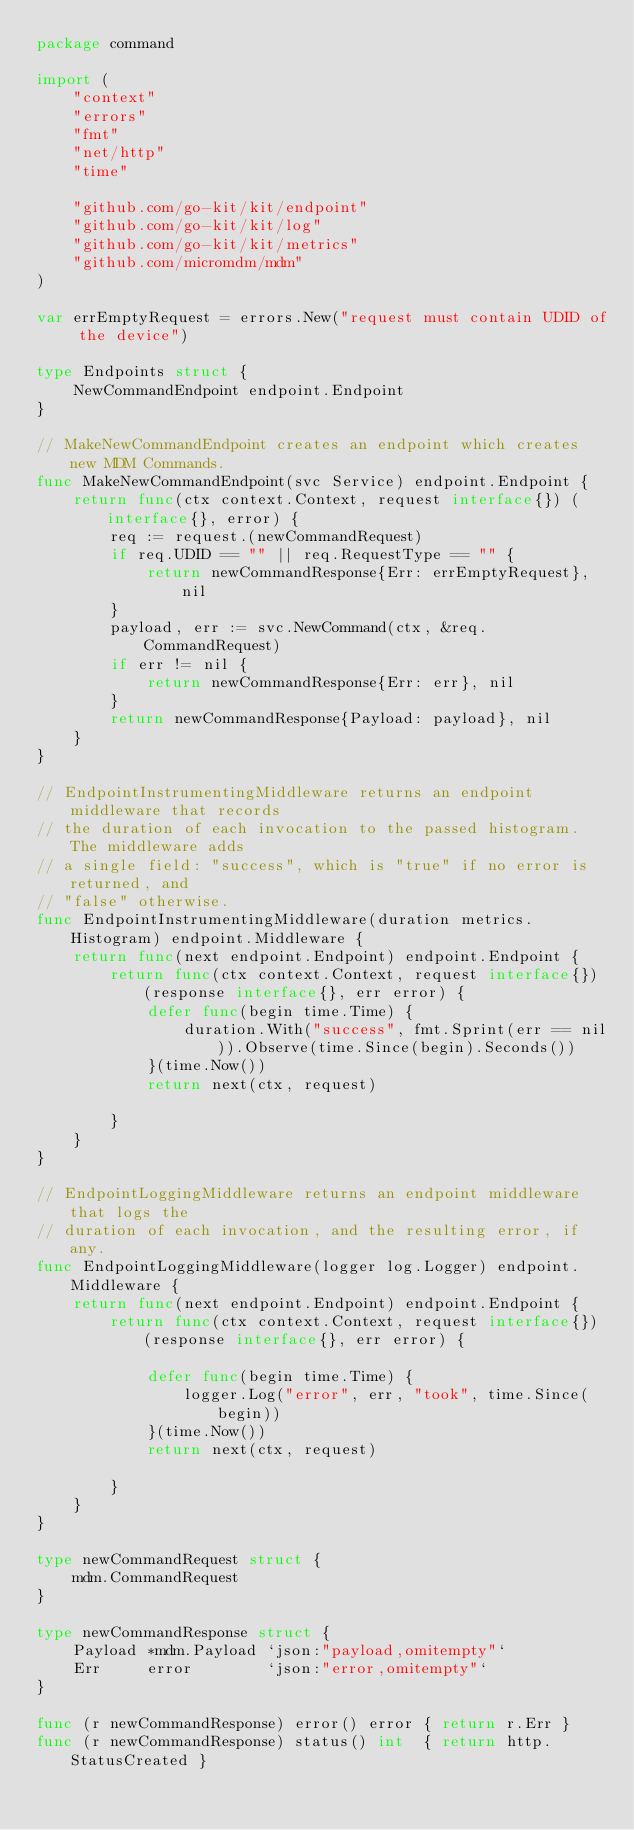<code> <loc_0><loc_0><loc_500><loc_500><_Go_>package command

import (
	"context"
	"errors"
	"fmt"
	"net/http"
	"time"

	"github.com/go-kit/kit/endpoint"
	"github.com/go-kit/kit/log"
	"github.com/go-kit/kit/metrics"
	"github.com/micromdm/mdm"
)

var errEmptyRequest = errors.New("request must contain UDID of the device")

type Endpoints struct {
	NewCommandEndpoint endpoint.Endpoint
}

// MakeNewCommandEndpoint creates an endpoint which creates new MDM Commands.
func MakeNewCommandEndpoint(svc Service) endpoint.Endpoint {
	return func(ctx context.Context, request interface{}) (interface{}, error) {
		req := request.(newCommandRequest)
		if req.UDID == "" || req.RequestType == "" {
			return newCommandResponse{Err: errEmptyRequest}, nil
		}
		payload, err := svc.NewCommand(ctx, &req.CommandRequest)
		if err != nil {
			return newCommandResponse{Err: err}, nil
		}
		return newCommandResponse{Payload: payload}, nil
	}
}

// EndpointInstrumentingMiddleware returns an endpoint middleware that records
// the duration of each invocation to the passed histogram. The middleware adds
// a single field: "success", which is "true" if no error is returned, and
// "false" otherwise.
func EndpointInstrumentingMiddleware(duration metrics.Histogram) endpoint.Middleware {
	return func(next endpoint.Endpoint) endpoint.Endpoint {
		return func(ctx context.Context, request interface{}) (response interface{}, err error) {
			defer func(begin time.Time) {
				duration.With("success", fmt.Sprint(err == nil)).Observe(time.Since(begin).Seconds())
			}(time.Now())
			return next(ctx, request)

		}
	}
}

// EndpointLoggingMiddleware returns an endpoint middleware that logs the
// duration of each invocation, and the resulting error, if any.
func EndpointLoggingMiddleware(logger log.Logger) endpoint.Middleware {
	return func(next endpoint.Endpoint) endpoint.Endpoint {
		return func(ctx context.Context, request interface{}) (response interface{}, err error) {

			defer func(begin time.Time) {
				logger.Log("error", err, "took", time.Since(begin))
			}(time.Now())
			return next(ctx, request)

		}
	}
}

type newCommandRequest struct {
	mdm.CommandRequest
}

type newCommandResponse struct {
	Payload *mdm.Payload `json:"payload,omitempty"`
	Err     error        `json:"error,omitempty"`
}

func (r newCommandResponse) error() error { return r.Err }
func (r newCommandResponse) status() int  { return http.StatusCreated }
</code> 